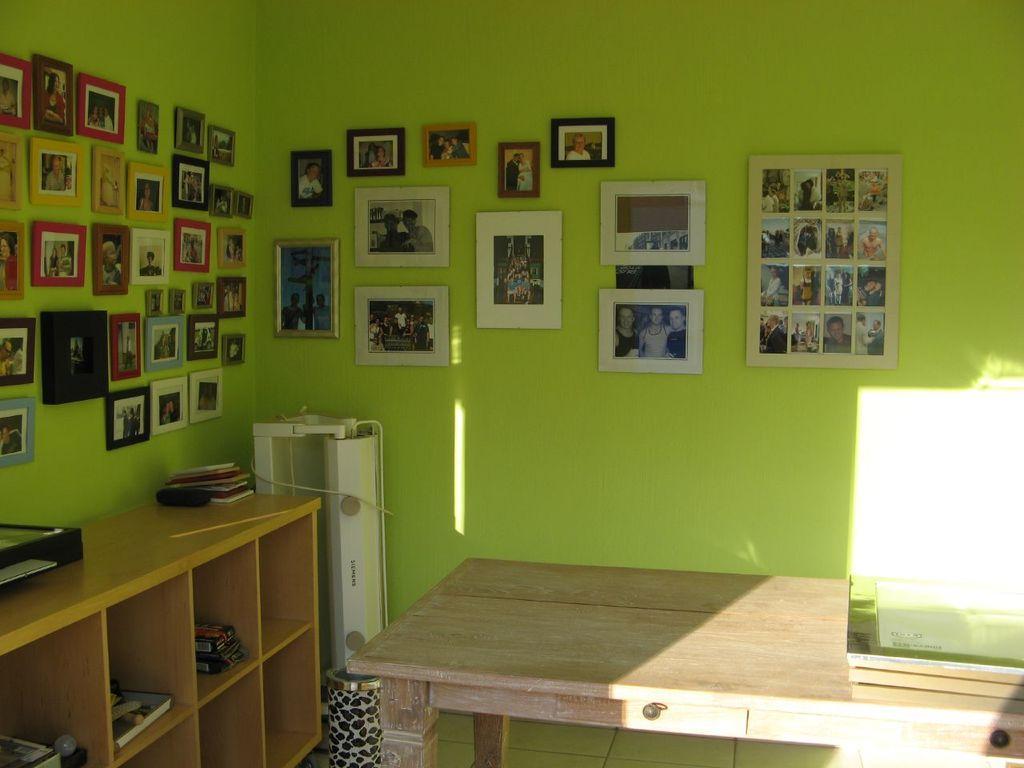Can you describe this image briefly? We can see table, device and bin. We can see books and objects in wooden racks. We can see objects on the wooden surface. We can see frames on the wall. 